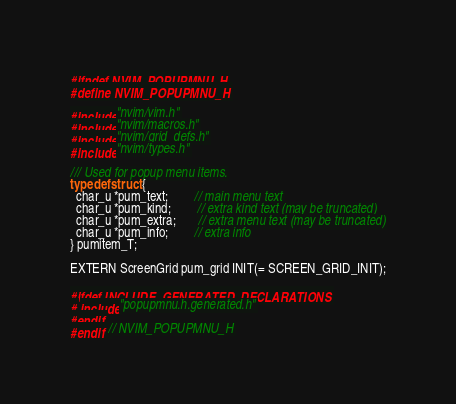Convert code to text. <code><loc_0><loc_0><loc_500><loc_500><_C_>#ifndef NVIM_POPUPMNU_H
#define NVIM_POPUPMNU_H

#include "nvim/vim.h"
#include "nvim/macros.h"
#include "nvim/grid_defs.h"
#include "nvim/types.h"

/// Used for popup menu items.
typedef struct {
  char_u *pum_text;        // main menu text
  char_u *pum_kind;        // extra kind text (may be truncated)
  char_u *pum_extra;       // extra menu text (may be truncated)
  char_u *pum_info;        // extra info
} pumitem_T;

EXTERN ScreenGrid pum_grid INIT(= SCREEN_GRID_INIT);

#ifdef INCLUDE_GENERATED_DECLARATIONS
# include "popupmnu.h.generated.h"
#endif
#endif  // NVIM_POPUPMNU_H
</code> 